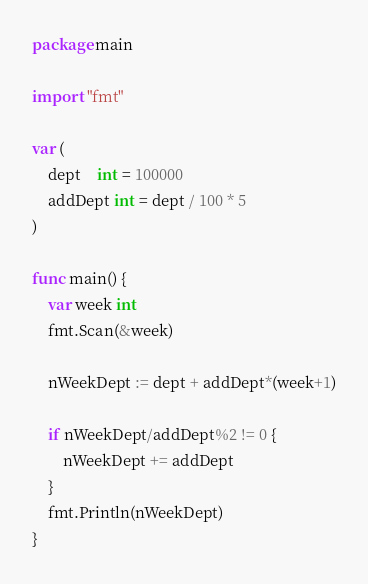Convert code to text. <code><loc_0><loc_0><loc_500><loc_500><_Go_>package main

import "fmt"

var (
	dept    int = 100000
	addDept int = dept / 100 * 5
)

func main() {
	var week int
	fmt.Scan(&week)

	nWeekDept := dept + addDept*(week+1)

	if nWeekDept/addDept%2 != 0 {
		nWeekDept += addDept
	}
	fmt.Println(nWeekDept)
}

</code> 